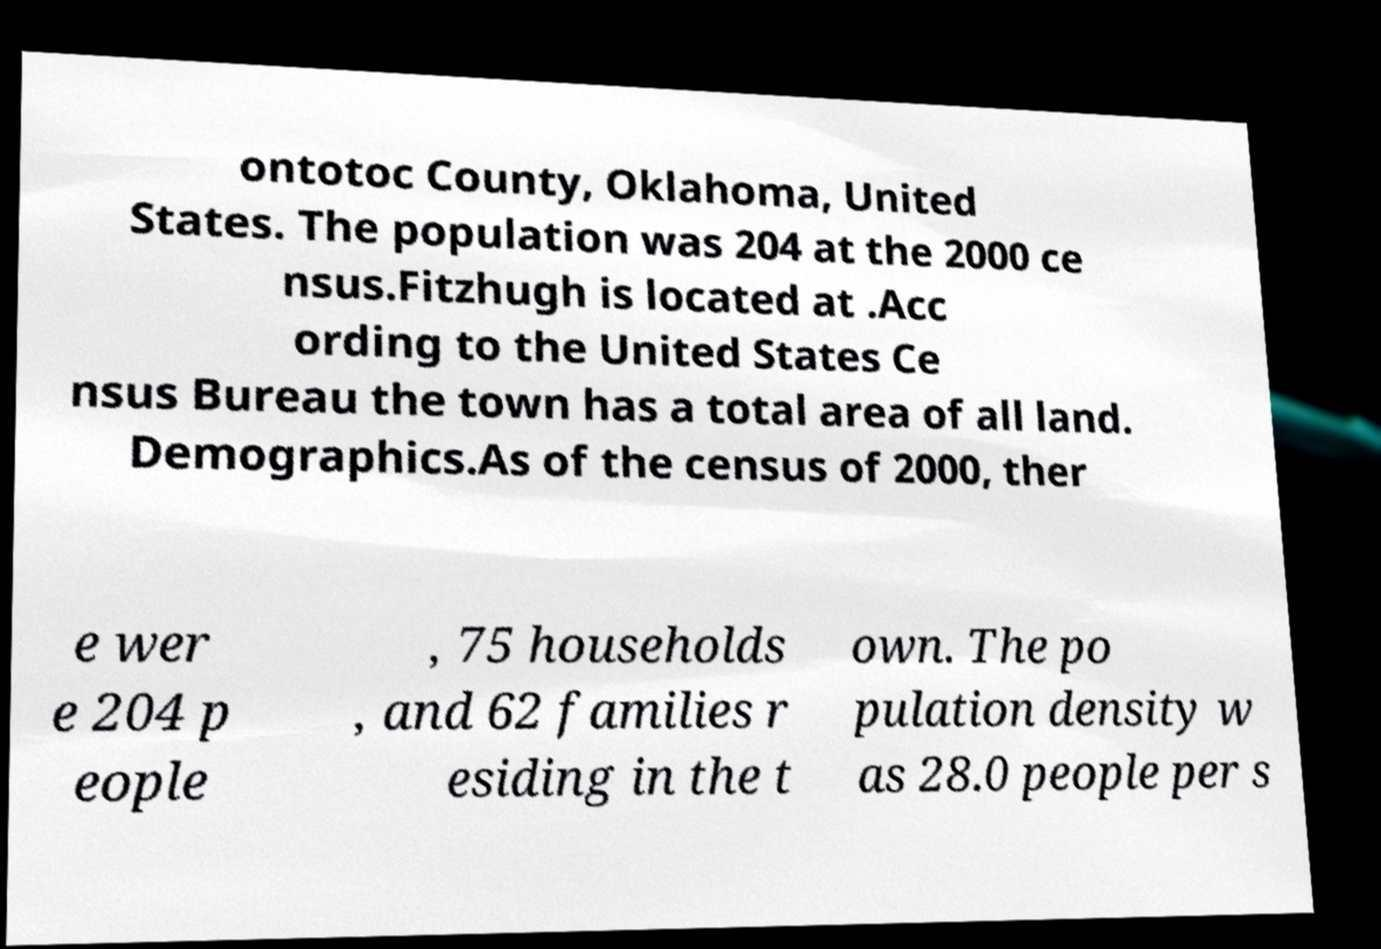Please identify and transcribe the text found in this image. ontotoc County, Oklahoma, United States. The population was 204 at the 2000 ce nsus.Fitzhugh is located at .Acc ording to the United States Ce nsus Bureau the town has a total area of all land. Demographics.As of the census of 2000, ther e wer e 204 p eople , 75 households , and 62 families r esiding in the t own. The po pulation density w as 28.0 people per s 